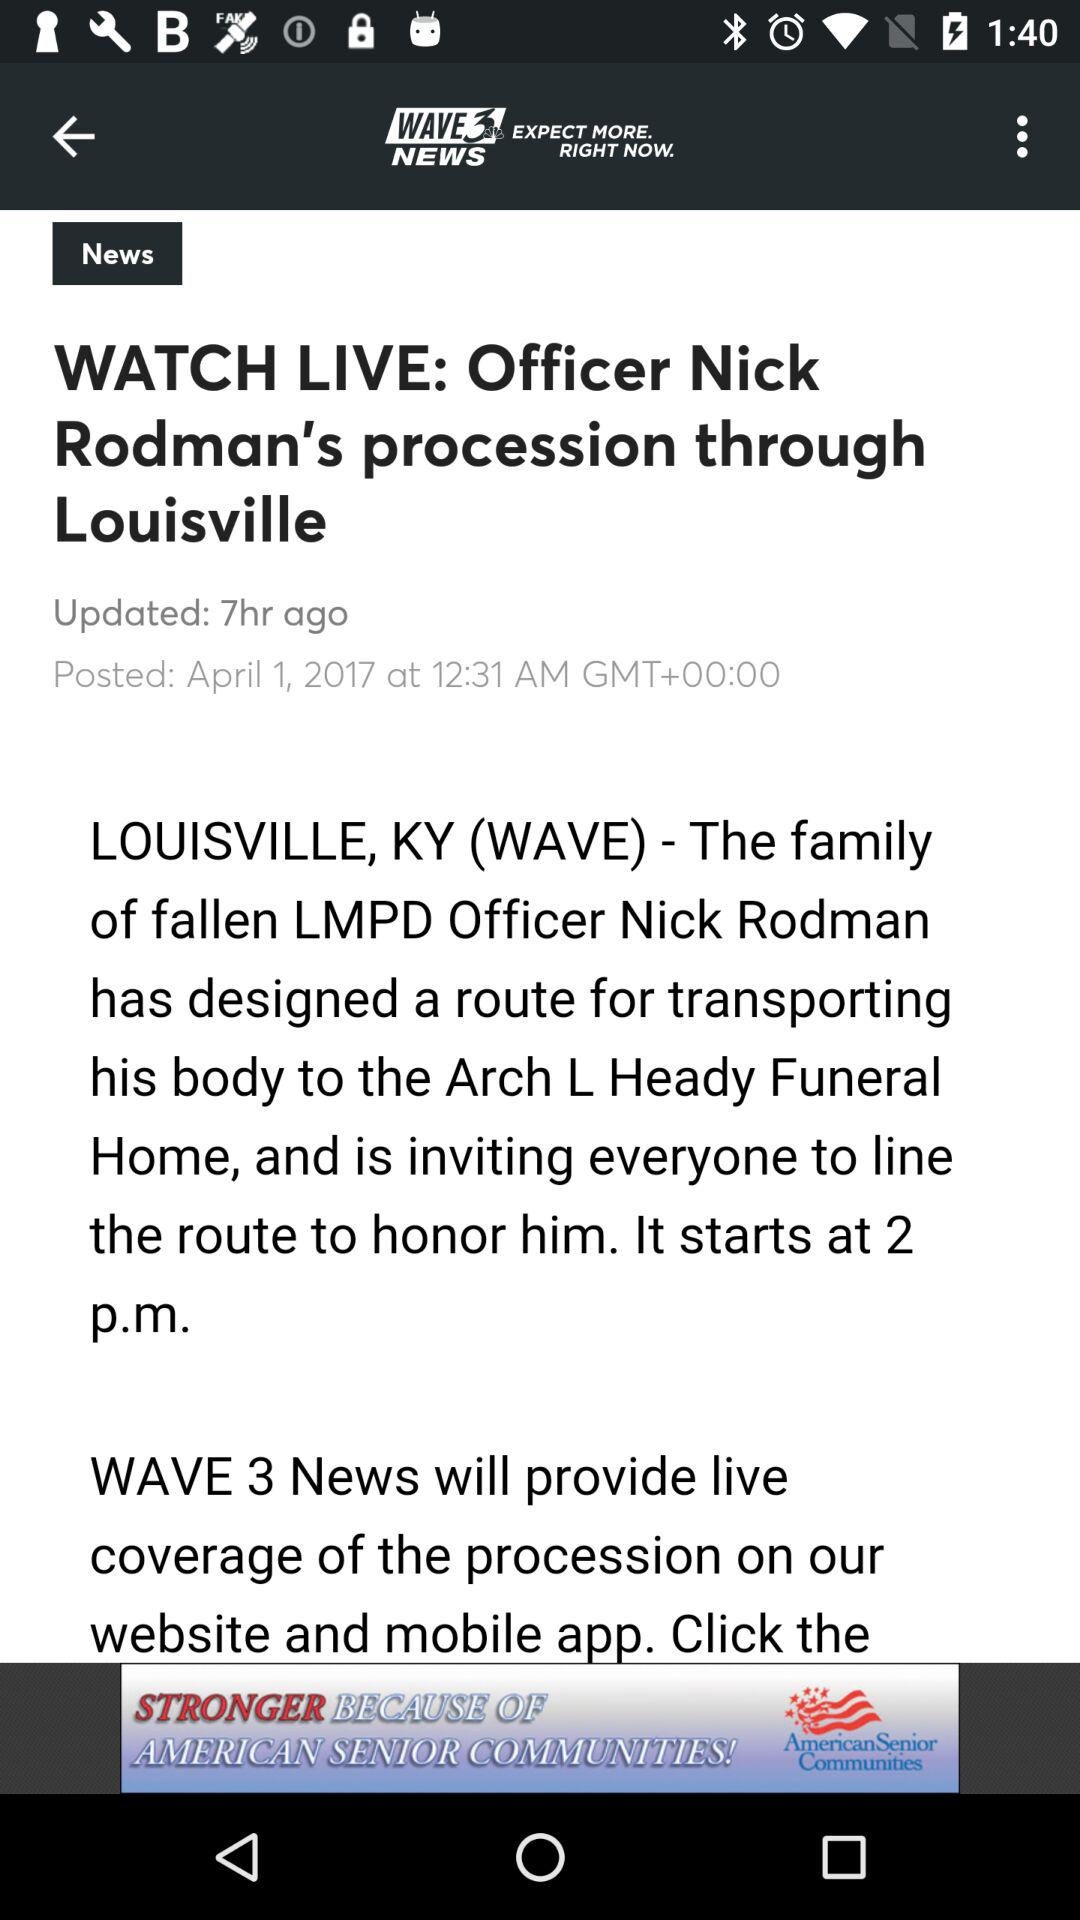How many hours ago was the article posted?
Answer the question using a single word or phrase. 7 